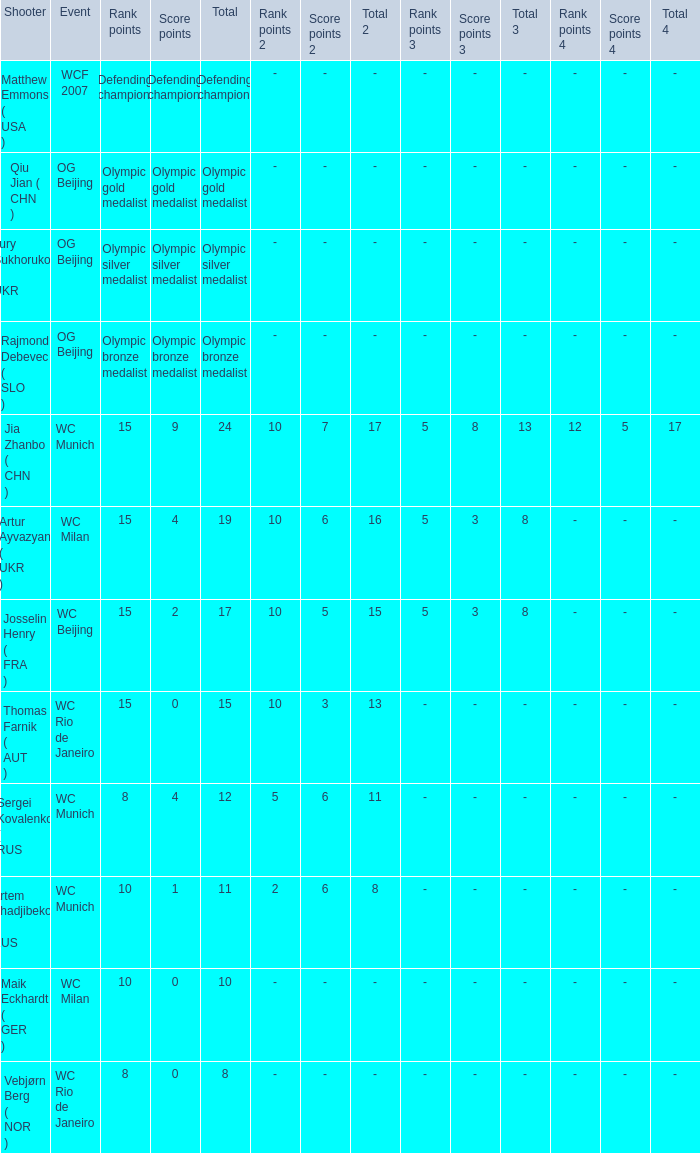With Olympic Bronze Medalist as the total what are the score points? Olympic bronze medalist. 